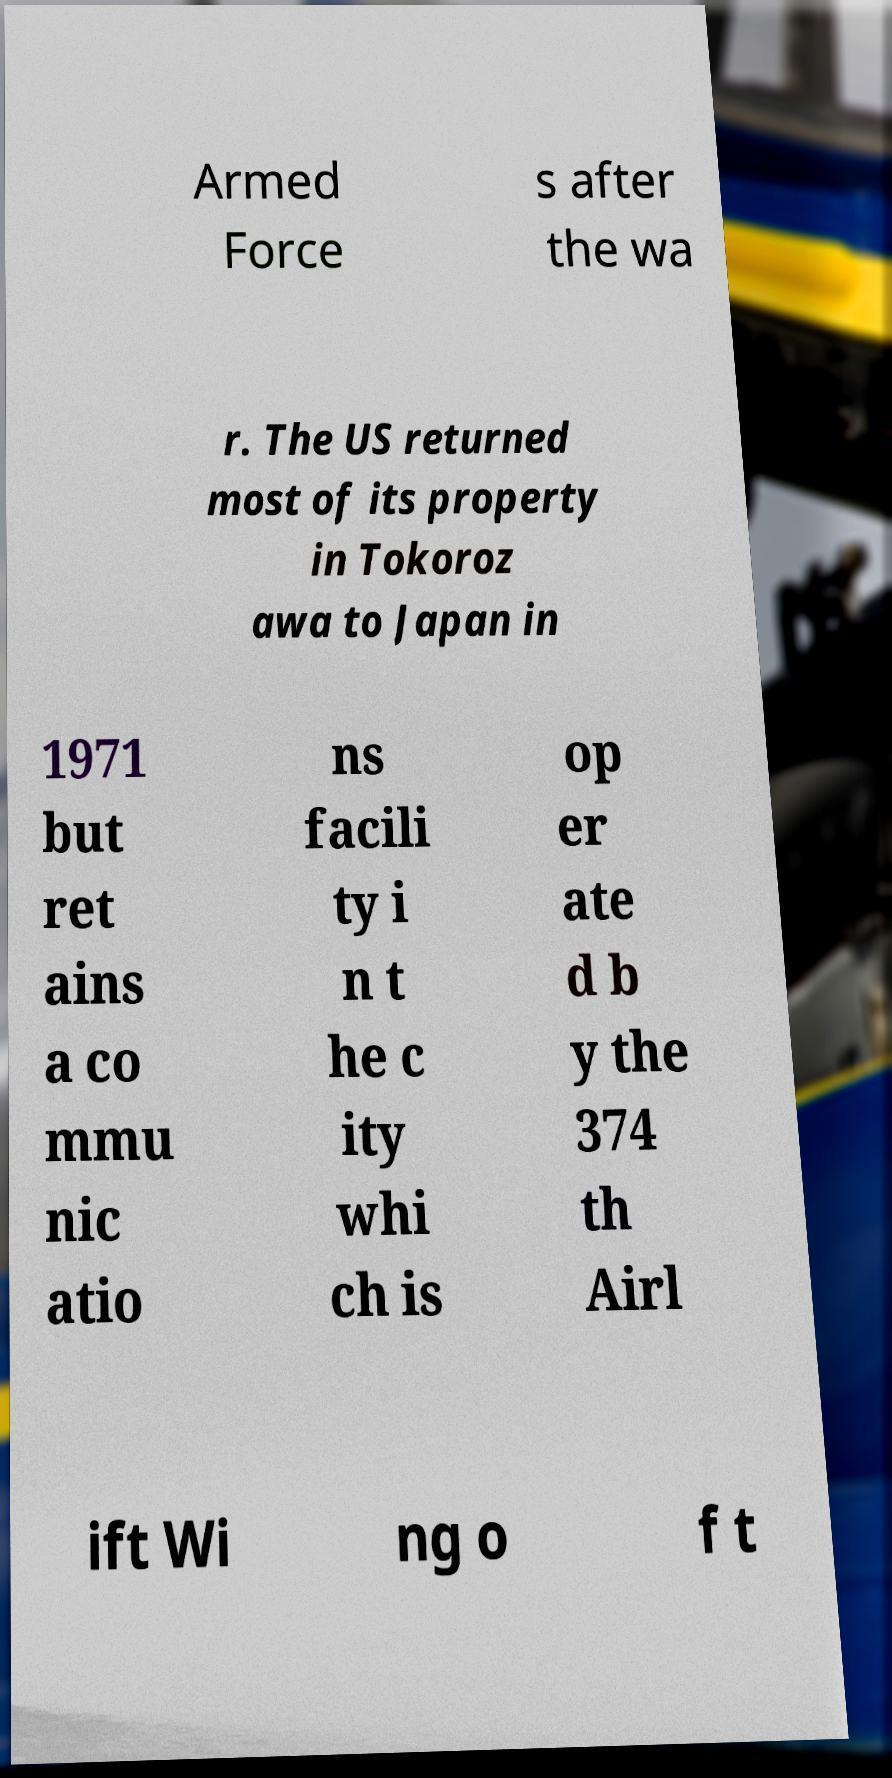There's text embedded in this image that I need extracted. Can you transcribe it verbatim? Armed Force s after the wa r. The US returned most of its property in Tokoroz awa to Japan in 1971 but ret ains a co mmu nic atio ns facili ty i n t he c ity whi ch is op er ate d b y the 374 th Airl ift Wi ng o f t 